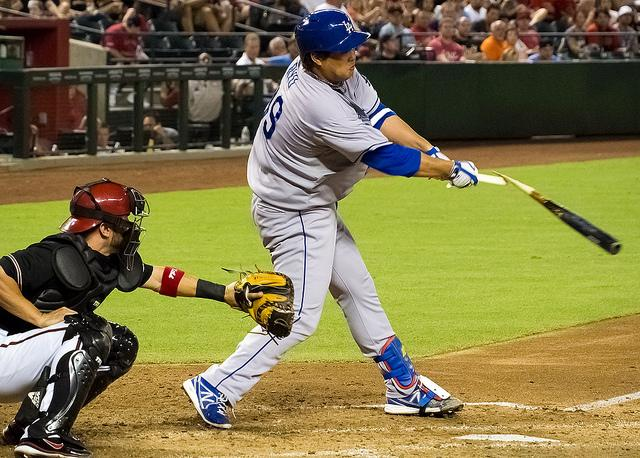What team is the batter playing for? dodgers 